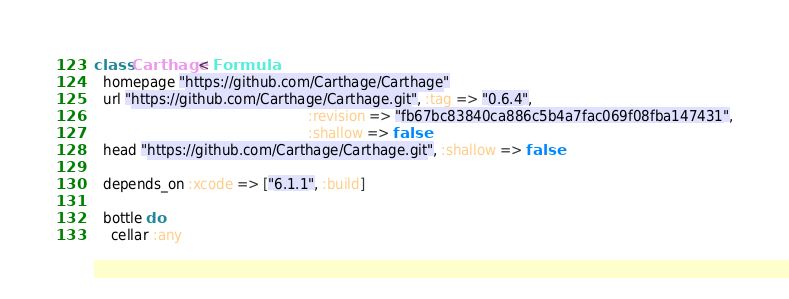Convert code to text. <code><loc_0><loc_0><loc_500><loc_500><_Ruby_>class Carthage < Formula
  homepage "https://github.com/Carthage/Carthage"
  url "https://github.com/Carthage/Carthage.git", :tag => "0.6.4",
                                                  :revision => "fb67bc83840ca886c5b4a7fac069f08fba147431",
                                                  :shallow => false
  head "https://github.com/Carthage/Carthage.git", :shallow => false

  depends_on :xcode => ["6.1.1", :build]

  bottle do
    cellar :any</code> 